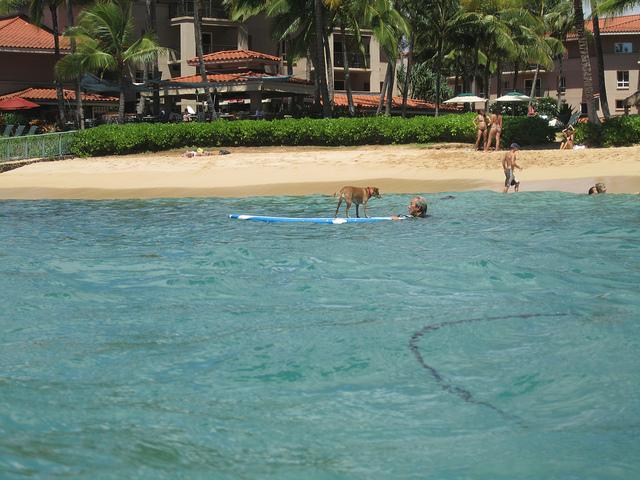What is preventing the dog from being submerged in the water? Please explain your reasoning. surf board. He is standing on top of it as it floats 